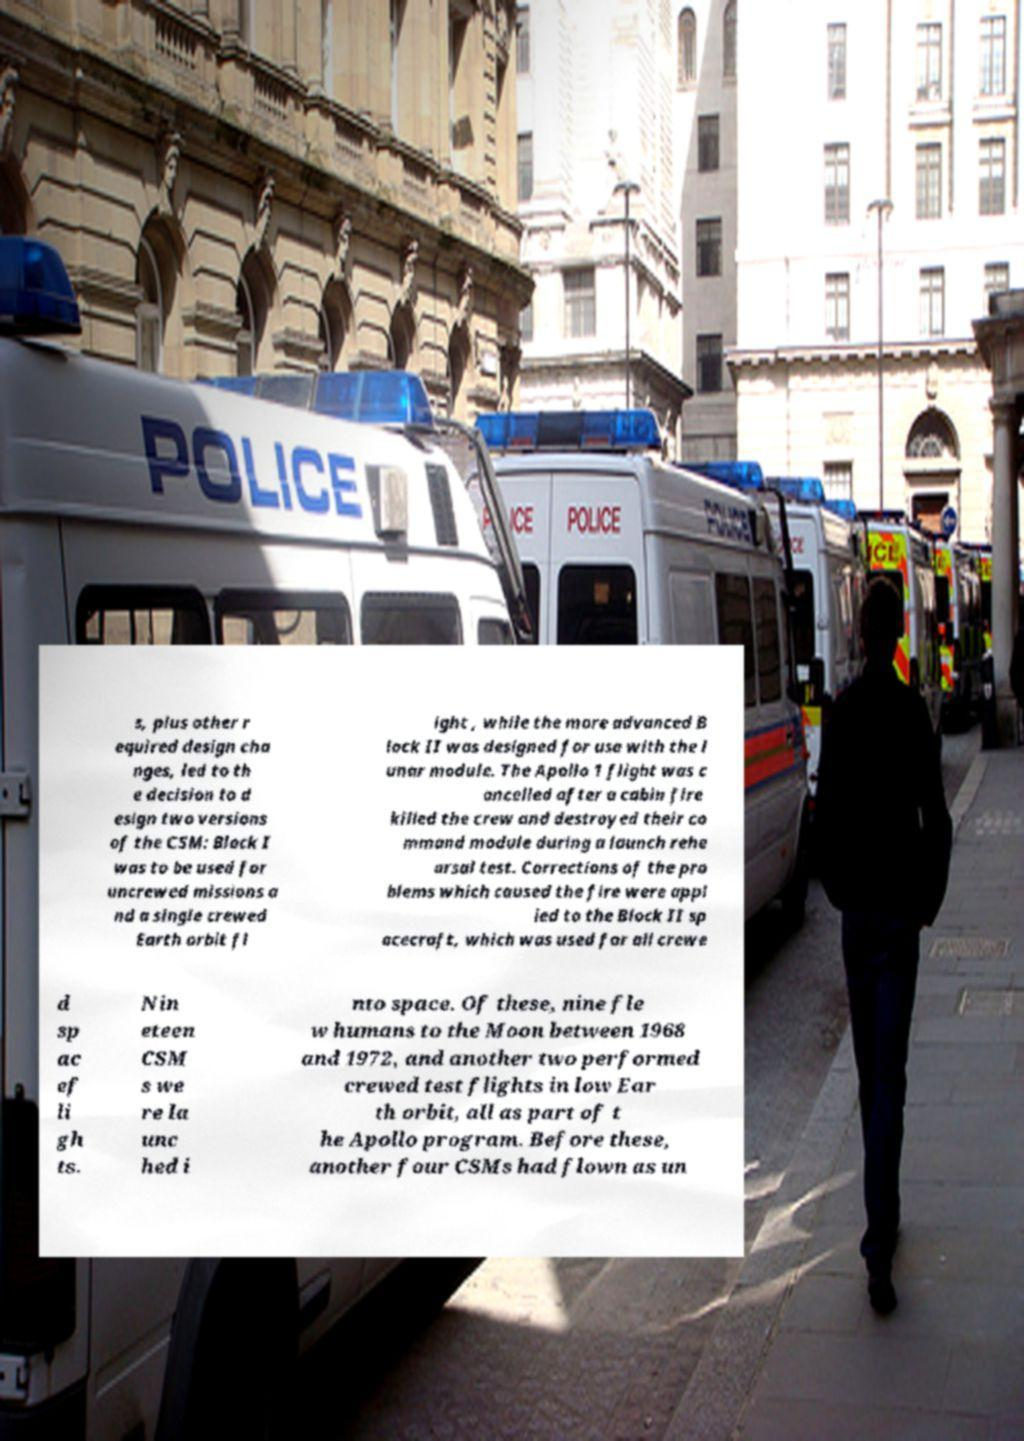I need the written content from this picture converted into text. Can you do that? s, plus other r equired design cha nges, led to th e decision to d esign two versions of the CSM: Block I was to be used for uncrewed missions a nd a single crewed Earth orbit fl ight , while the more advanced B lock II was designed for use with the l unar module. The Apollo 1 flight was c ancelled after a cabin fire killed the crew and destroyed their co mmand module during a launch rehe arsal test. Corrections of the pro blems which caused the fire were appl ied to the Block II sp acecraft, which was used for all crewe d sp ac ef li gh ts. Nin eteen CSM s we re la unc hed i nto space. Of these, nine fle w humans to the Moon between 1968 and 1972, and another two performed crewed test flights in low Ear th orbit, all as part of t he Apollo program. Before these, another four CSMs had flown as un 